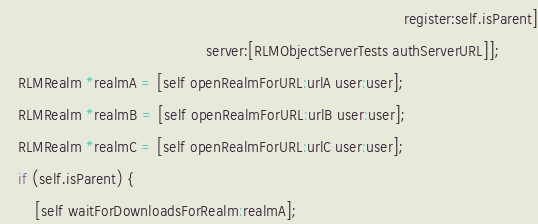Convert code to text. <code><loc_0><loc_0><loc_500><loc_500><_ObjectiveC_>                                                                                            register:self.isParent]
                                               server:[RLMObjectServerTests authServerURL]];
    RLMRealm *realmA = [self openRealmForURL:urlA user:user];
    RLMRealm *realmB = [self openRealmForURL:urlB user:user];
    RLMRealm *realmC = [self openRealmForURL:urlC user:user];
    if (self.isParent) {
        [self waitForDownloadsForRealm:realmA];</code> 